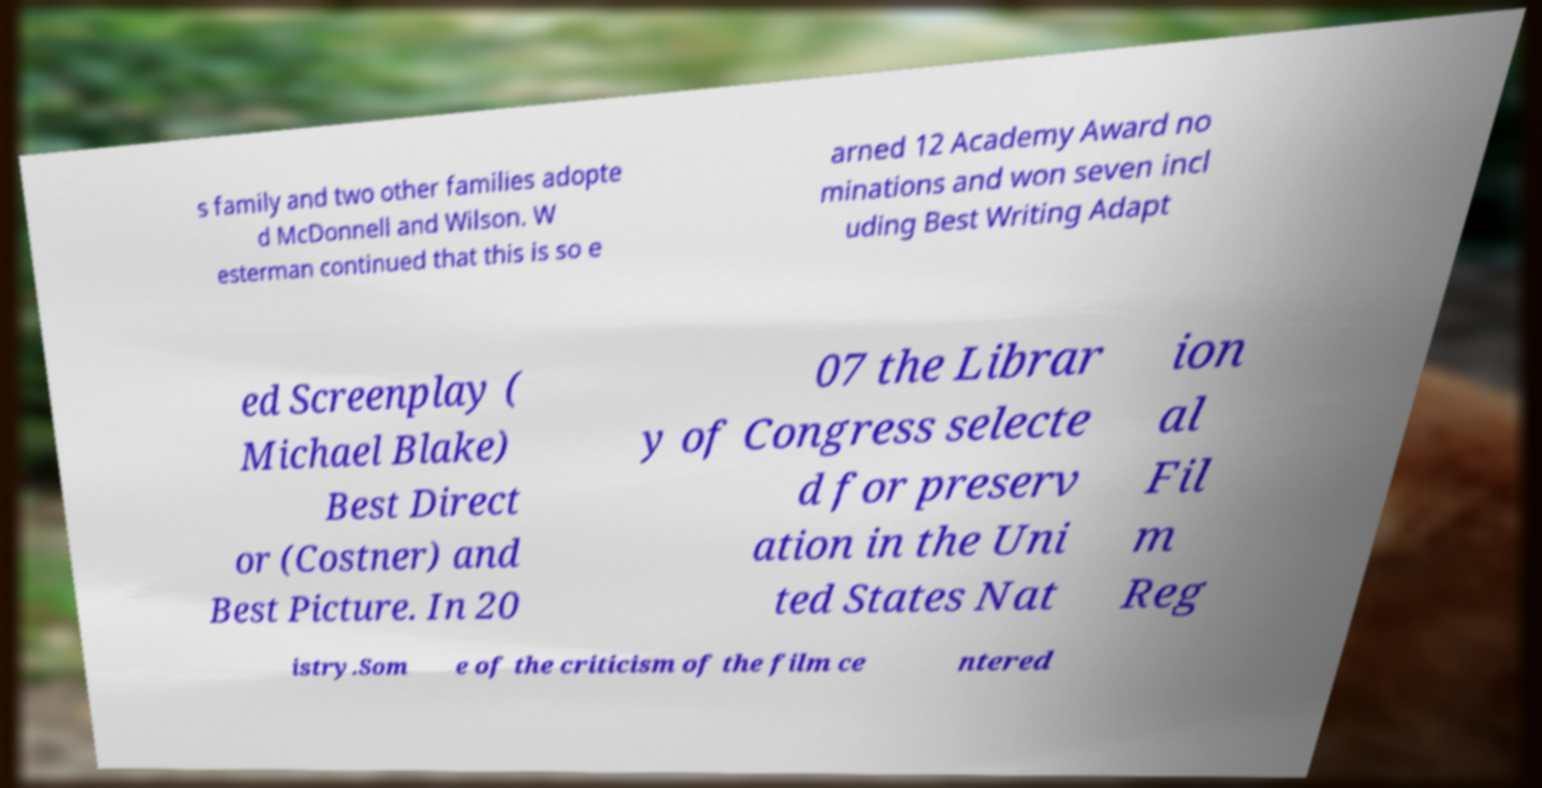Please read and relay the text visible in this image. What does it say? s family and two other families adopte d McDonnell and Wilson. W esterman continued that this is so e arned 12 Academy Award no minations and won seven incl uding Best Writing Adapt ed Screenplay ( Michael Blake) Best Direct or (Costner) and Best Picture. In 20 07 the Librar y of Congress selecte d for preserv ation in the Uni ted States Nat ion al Fil m Reg istry.Som e of the criticism of the film ce ntered 